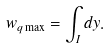Convert formula to latex. <formula><loc_0><loc_0><loc_500><loc_500>w _ { q \max } = \int _ { I } d y .</formula> 